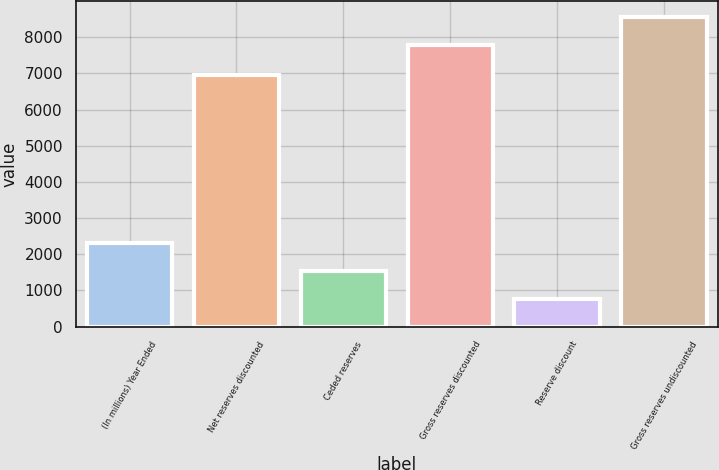<chart> <loc_0><loc_0><loc_500><loc_500><bar_chart><fcel>(In millions) Year Ended<fcel>Net reserves discounted<fcel>Ceded reserves<fcel>Gross reserves discounted<fcel>Reserve discount<fcel>Gross reserves undiscounted<nl><fcel>2317.8<fcel>6947<fcel>1539.4<fcel>7784<fcel>761<fcel>8562.4<nl></chart> 